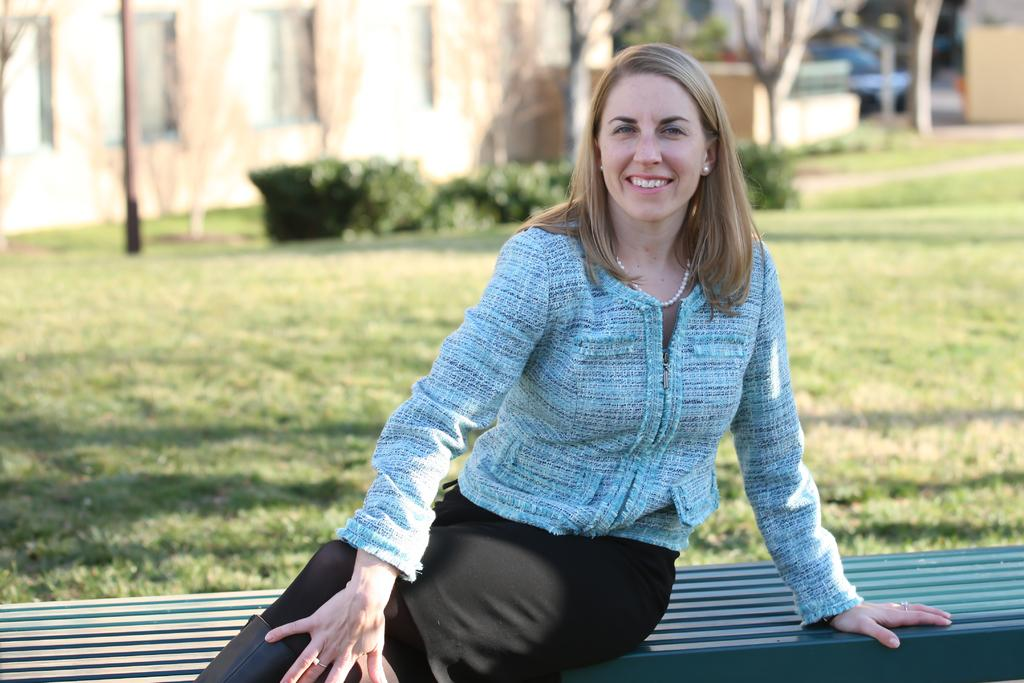What is the woman in the image doing? The woman is sitting in the image. What is the woman wearing? The woman is wearing clothes, a neck chain, ear studs, and a finger ring. What is the woman's facial expression? The woman is smiling in the image. What can be seen in the foreground of the image? There is grass and a pole in the image. How would you describe the background of the image? The background of the image is blurred. What type of baseball is the woman holding in the image? There is no baseball present in the image. How many thumbs does the woman have on her hand in the image? The image does not show the woman's hand or thumbs, so it cannot be determined from the image. 